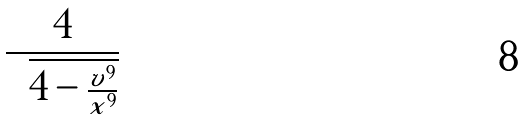Convert formula to latex. <formula><loc_0><loc_0><loc_500><loc_500>\frac { 4 } { \sqrt { 4 - \frac { v ^ { 9 } } { x ^ { 9 } } } }</formula> 